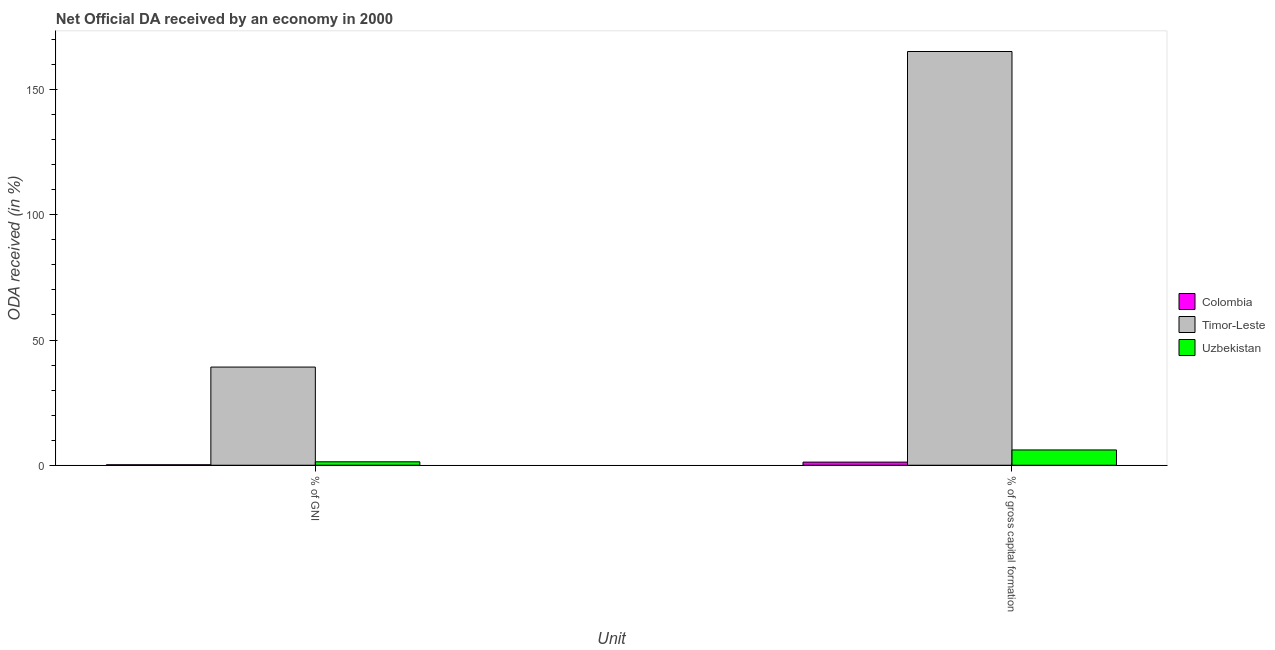How many groups of bars are there?
Your answer should be compact. 2. Are the number of bars per tick equal to the number of legend labels?
Keep it short and to the point. Yes. How many bars are there on the 1st tick from the left?
Your answer should be very brief. 3. How many bars are there on the 2nd tick from the right?
Provide a succinct answer. 3. What is the label of the 1st group of bars from the left?
Keep it short and to the point. % of GNI. What is the oda received as percentage of gni in Uzbekistan?
Ensure brevity in your answer.  1.37. Across all countries, what is the maximum oda received as percentage of gross capital formation?
Give a very brief answer. 165.19. Across all countries, what is the minimum oda received as percentage of gni?
Offer a very short reply. 0.19. In which country was the oda received as percentage of gross capital formation maximum?
Your response must be concise. Timor-Leste. What is the total oda received as percentage of gross capital formation in the graph?
Provide a short and direct response. 172.55. What is the difference between the oda received as percentage of gni in Uzbekistan and that in Timor-Leste?
Provide a succinct answer. -37.83. What is the difference between the oda received as percentage of gni in Timor-Leste and the oda received as percentage of gross capital formation in Uzbekistan?
Your answer should be compact. 33.09. What is the average oda received as percentage of gni per country?
Offer a terse response. 13.59. What is the difference between the oda received as percentage of gross capital formation and oda received as percentage of gni in Uzbekistan?
Your answer should be compact. 4.74. In how many countries, is the oda received as percentage of gross capital formation greater than 110 %?
Provide a short and direct response. 1. What is the ratio of the oda received as percentage of gni in Uzbekistan to that in Colombia?
Provide a short and direct response. 7.21. Is the oda received as percentage of gross capital formation in Colombia less than that in Timor-Leste?
Offer a very short reply. Yes. In how many countries, is the oda received as percentage of gni greater than the average oda received as percentage of gni taken over all countries?
Make the answer very short. 1. What does the 2nd bar from the left in % of GNI represents?
Provide a succinct answer. Timor-Leste. What does the 2nd bar from the right in % of gross capital formation represents?
Give a very brief answer. Timor-Leste. How many bars are there?
Your answer should be compact. 6. How many countries are there in the graph?
Your answer should be very brief. 3. Where does the legend appear in the graph?
Provide a succinct answer. Center right. How many legend labels are there?
Make the answer very short. 3. What is the title of the graph?
Offer a very short reply. Net Official DA received by an economy in 2000. Does "Benin" appear as one of the legend labels in the graph?
Ensure brevity in your answer.  No. What is the label or title of the X-axis?
Offer a terse response. Unit. What is the label or title of the Y-axis?
Your answer should be very brief. ODA received (in %). What is the ODA received (in %) of Colombia in % of GNI?
Your answer should be compact. 0.19. What is the ODA received (in %) in Timor-Leste in % of GNI?
Provide a short and direct response. 39.2. What is the ODA received (in %) of Uzbekistan in % of GNI?
Give a very brief answer. 1.37. What is the ODA received (in %) in Colombia in % of gross capital formation?
Make the answer very short. 1.25. What is the ODA received (in %) in Timor-Leste in % of gross capital formation?
Give a very brief answer. 165.19. What is the ODA received (in %) of Uzbekistan in % of gross capital formation?
Ensure brevity in your answer.  6.11. Across all Unit, what is the maximum ODA received (in %) in Colombia?
Provide a succinct answer. 1.25. Across all Unit, what is the maximum ODA received (in %) in Timor-Leste?
Make the answer very short. 165.19. Across all Unit, what is the maximum ODA received (in %) in Uzbekistan?
Your answer should be compact. 6.11. Across all Unit, what is the minimum ODA received (in %) of Colombia?
Ensure brevity in your answer.  0.19. Across all Unit, what is the minimum ODA received (in %) in Timor-Leste?
Offer a terse response. 39.2. Across all Unit, what is the minimum ODA received (in %) of Uzbekistan?
Keep it short and to the point. 1.37. What is the total ODA received (in %) in Colombia in the graph?
Offer a very short reply. 1.44. What is the total ODA received (in %) in Timor-Leste in the graph?
Give a very brief answer. 204.39. What is the total ODA received (in %) in Uzbekistan in the graph?
Your answer should be very brief. 7.48. What is the difference between the ODA received (in %) in Colombia in % of GNI and that in % of gross capital formation?
Your answer should be compact. -1.06. What is the difference between the ODA received (in %) in Timor-Leste in % of GNI and that in % of gross capital formation?
Ensure brevity in your answer.  -125.99. What is the difference between the ODA received (in %) of Uzbekistan in % of GNI and that in % of gross capital formation?
Give a very brief answer. -4.74. What is the difference between the ODA received (in %) in Colombia in % of GNI and the ODA received (in %) in Timor-Leste in % of gross capital formation?
Provide a short and direct response. -165. What is the difference between the ODA received (in %) of Colombia in % of GNI and the ODA received (in %) of Uzbekistan in % of gross capital formation?
Your response must be concise. -5.92. What is the difference between the ODA received (in %) of Timor-Leste in % of GNI and the ODA received (in %) of Uzbekistan in % of gross capital formation?
Give a very brief answer. 33.09. What is the average ODA received (in %) in Colombia per Unit?
Keep it short and to the point. 0.72. What is the average ODA received (in %) of Timor-Leste per Unit?
Give a very brief answer. 102.2. What is the average ODA received (in %) in Uzbekistan per Unit?
Provide a short and direct response. 3.74. What is the difference between the ODA received (in %) in Colombia and ODA received (in %) in Timor-Leste in % of GNI?
Make the answer very short. -39.01. What is the difference between the ODA received (in %) in Colombia and ODA received (in %) in Uzbekistan in % of GNI?
Keep it short and to the point. -1.18. What is the difference between the ODA received (in %) of Timor-Leste and ODA received (in %) of Uzbekistan in % of GNI?
Make the answer very short. 37.83. What is the difference between the ODA received (in %) in Colombia and ODA received (in %) in Timor-Leste in % of gross capital formation?
Your response must be concise. -163.94. What is the difference between the ODA received (in %) of Colombia and ODA received (in %) of Uzbekistan in % of gross capital formation?
Provide a short and direct response. -4.86. What is the difference between the ODA received (in %) in Timor-Leste and ODA received (in %) in Uzbekistan in % of gross capital formation?
Your answer should be very brief. 159.08. What is the ratio of the ODA received (in %) in Colombia in % of GNI to that in % of gross capital formation?
Give a very brief answer. 0.15. What is the ratio of the ODA received (in %) of Timor-Leste in % of GNI to that in % of gross capital formation?
Ensure brevity in your answer.  0.24. What is the ratio of the ODA received (in %) of Uzbekistan in % of GNI to that in % of gross capital formation?
Your answer should be very brief. 0.22. What is the difference between the highest and the second highest ODA received (in %) in Colombia?
Ensure brevity in your answer.  1.06. What is the difference between the highest and the second highest ODA received (in %) of Timor-Leste?
Offer a terse response. 125.99. What is the difference between the highest and the second highest ODA received (in %) of Uzbekistan?
Your answer should be very brief. 4.74. What is the difference between the highest and the lowest ODA received (in %) of Colombia?
Ensure brevity in your answer.  1.06. What is the difference between the highest and the lowest ODA received (in %) in Timor-Leste?
Make the answer very short. 125.99. What is the difference between the highest and the lowest ODA received (in %) in Uzbekistan?
Make the answer very short. 4.74. 